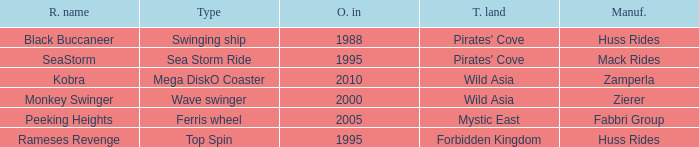What ride was manufactured by Zierer? Monkey Swinger. 